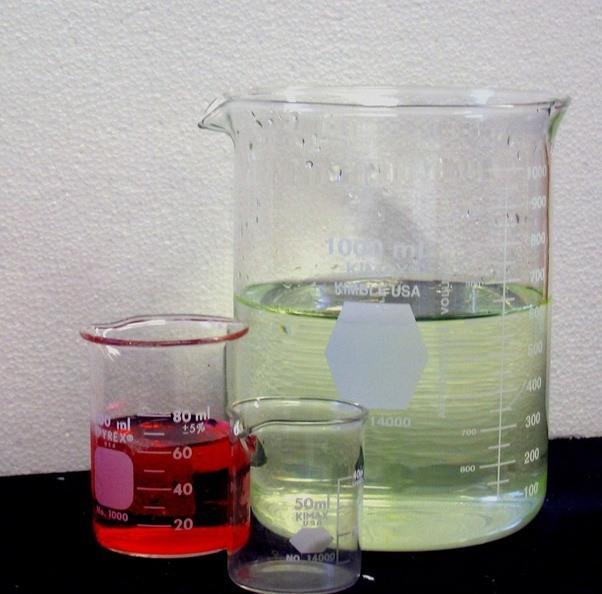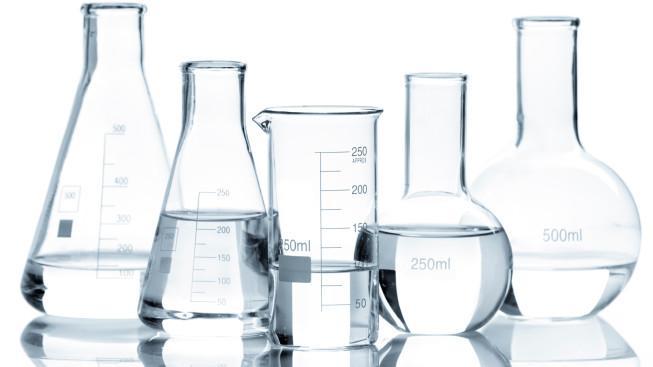The first image is the image on the left, the second image is the image on the right. Given the left and right images, does the statement "There is one empty container in the left image." hold true? Answer yes or no. Yes. The first image is the image on the left, the second image is the image on the right. Evaluate the accuracy of this statement regarding the images: "There are two science beakers.". Is it true? Answer yes or no. No. 